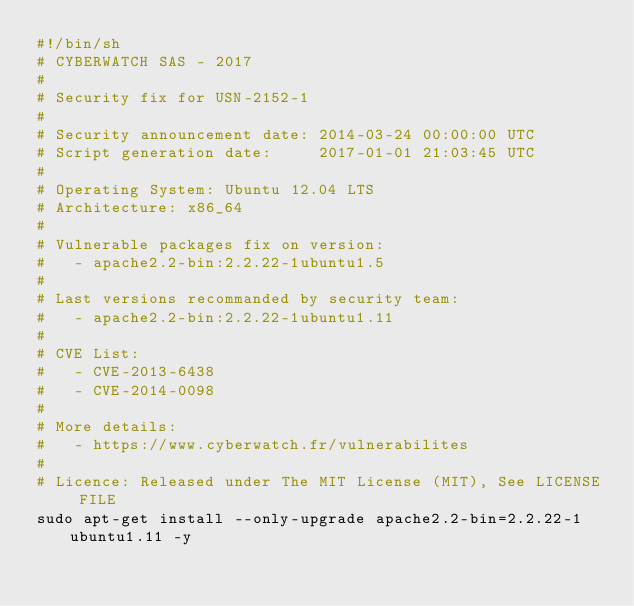<code> <loc_0><loc_0><loc_500><loc_500><_Bash_>#!/bin/sh
# CYBERWATCH SAS - 2017
#
# Security fix for USN-2152-1
#
# Security announcement date: 2014-03-24 00:00:00 UTC
# Script generation date:     2017-01-01 21:03:45 UTC
#
# Operating System: Ubuntu 12.04 LTS
# Architecture: x86_64
#
# Vulnerable packages fix on version:
#   - apache2.2-bin:2.2.22-1ubuntu1.5
#
# Last versions recommanded by security team:
#   - apache2.2-bin:2.2.22-1ubuntu1.11
#
# CVE List:
#   - CVE-2013-6438
#   - CVE-2014-0098
#
# More details:
#   - https://www.cyberwatch.fr/vulnerabilites
#
# Licence: Released under The MIT License (MIT), See LICENSE FILE
sudo apt-get install --only-upgrade apache2.2-bin=2.2.22-1ubuntu1.11 -y
</code> 